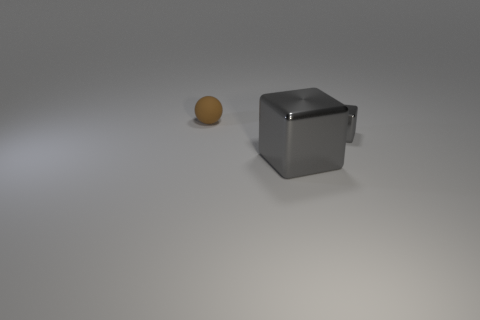Add 3 small objects. How many objects exist? 6 Subtract 0 red cylinders. How many objects are left? 3 Subtract all blocks. How many objects are left? 1 Subtract all tiny green rubber objects. Subtract all rubber balls. How many objects are left? 2 Add 3 brown matte spheres. How many brown matte spheres are left? 4 Add 2 brown spheres. How many brown spheres exist? 3 